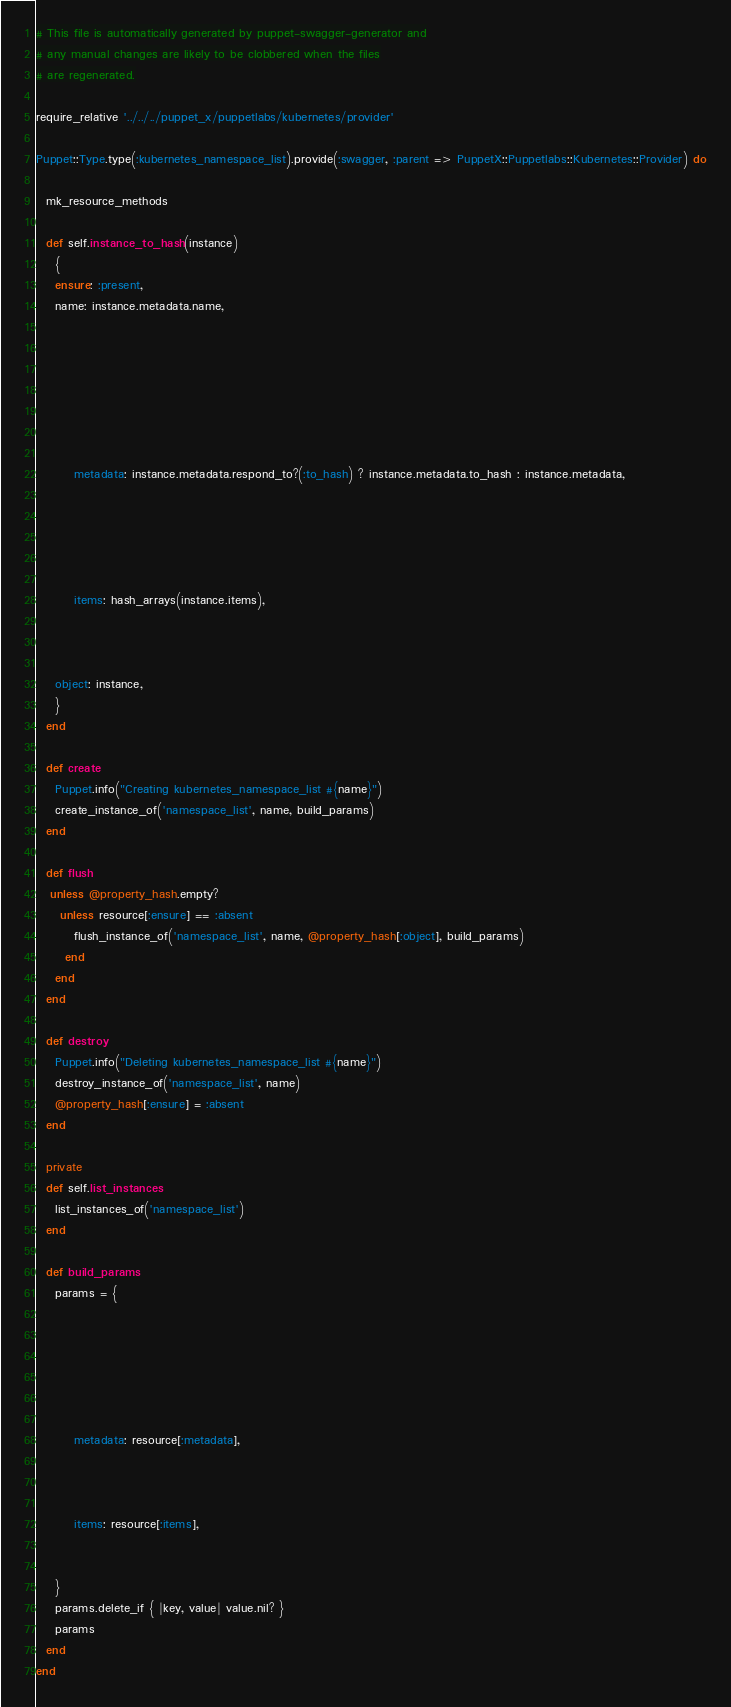Convert code to text. <code><loc_0><loc_0><loc_500><loc_500><_Ruby_>
# This file is automatically generated by puppet-swagger-generator and
# any manual changes are likely to be clobbered when the files
# are regenerated.

require_relative '../../../puppet_x/puppetlabs/kubernetes/provider'

Puppet::Type.type(:kubernetes_namespace_list).provide(:swagger, :parent => PuppetX::Puppetlabs::Kubernetes::Provider) do

  mk_resource_methods

  def self.instance_to_hash(instance)
    {
    ensure: :present,
    name: instance.metadata.name,
    
      
    
      
    
      
        
        metadata: instance.metadata.respond_to?(:to_hash) ? instance.metadata.to_hash : instance.metadata,
        
      
    
      
        
        items: hash_arrays(instance.items),
        
      
    
    object: instance,
    }
  end

  def create
    Puppet.info("Creating kubernetes_namespace_list #{name}")
    create_instance_of('namespace_list', name, build_params)
  end

  def flush
   unless @property_hash.empty?
     unless resource[:ensure] == :absent
        flush_instance_of('namespace_list', name, @property_hash[:object], build_params)
      end
    end
  end

  def destroy
    Puppet.info("Deleting kubernetes_namespace_list #{name}")
    destroy_instance_of('namespace_list', name)
    @property_hash[:ensure] = :absent
  end

  private
  def self.list_instances
    list_instances_of('namespace_list')
  end

  def build_params
    params = {
    
      
    
      
    
      
        metadata: resource[:metadata],
      
    
      
        items: resource[:items],
      
    
    }
    params.delete_if { |key, value| value.nil? }
    params
  end
end
</code> 